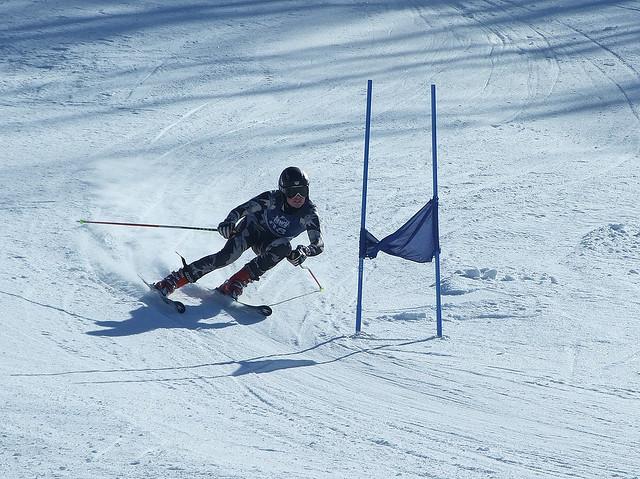Is this person going fast?
Answer briefly. Yes. What color is the flag?
Answer briefly. Blue. Is the person going to hit the obstacle?
Write a very short answer. No. What color are flags?
Quick response, please. Blue. Has anyone else been skiing?
Answer briefly. Yes. 